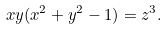Convert formula to latex. <formula><loc_0><loc_0><loc_500><loc_500>x y ( x ^ { 2 } + y ^ { 2 } - 1 ) = z ^ { 3 } .</formula> 